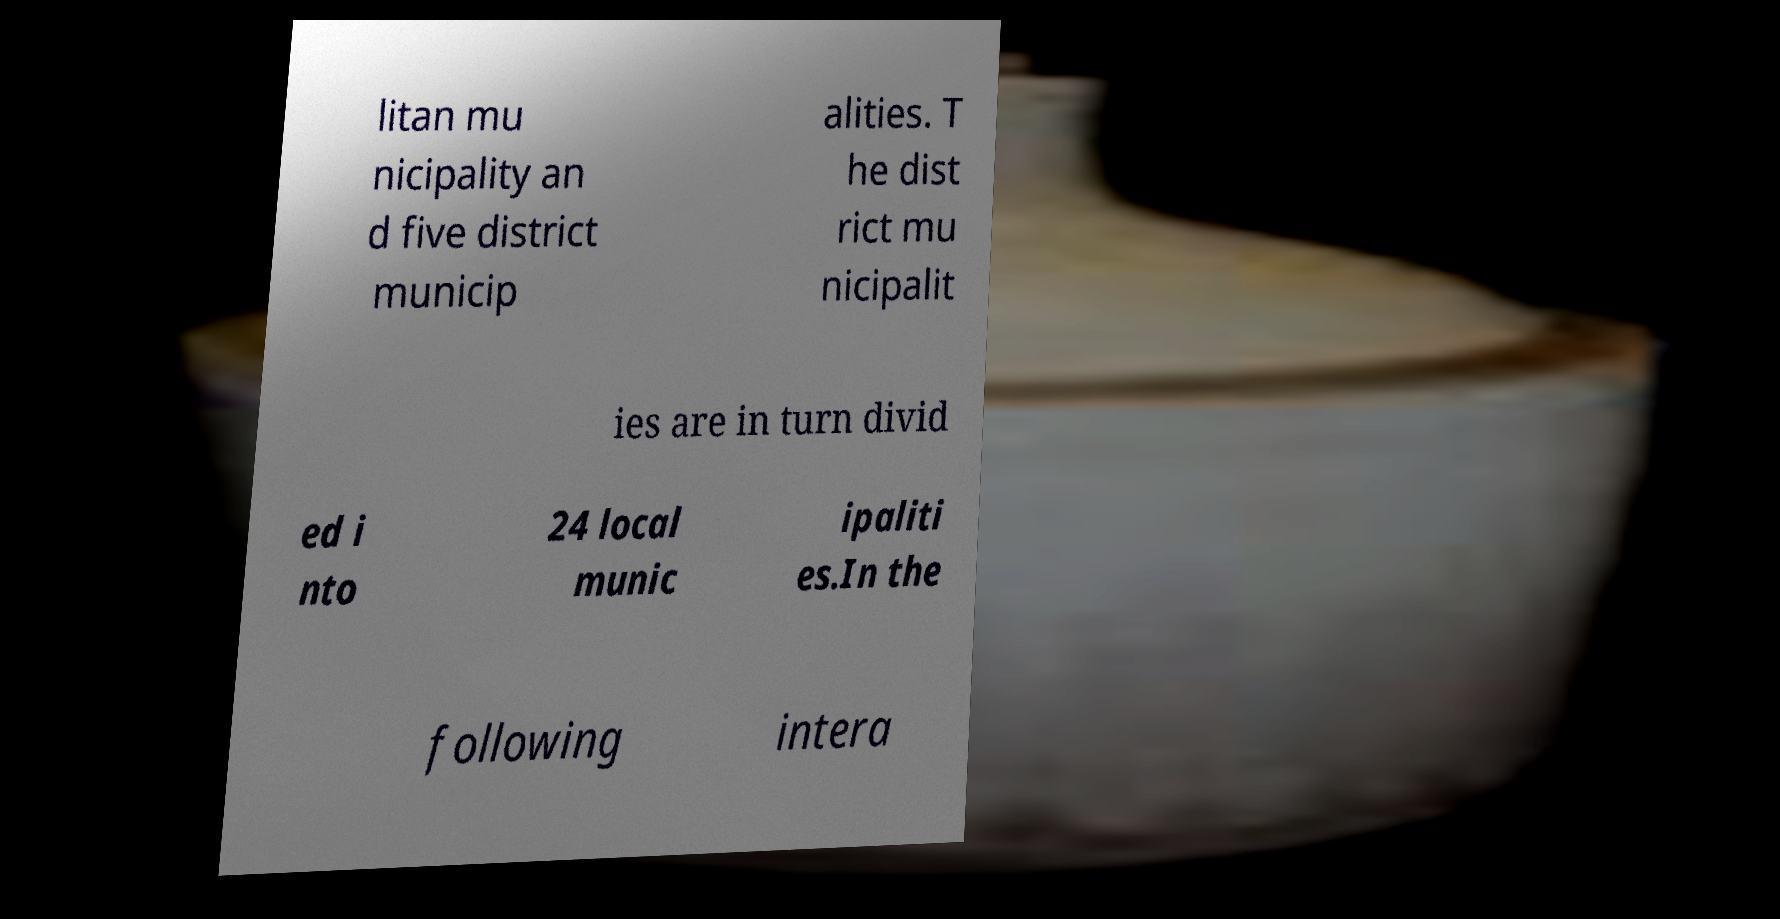Please read and relay the text visible in this image. What does it say? litan mu nicipality an d five district municip alities. T he dist rict mu nicipalit ies are in turn divid ed i nto 24 local munic ipaliti es.In the following intera 